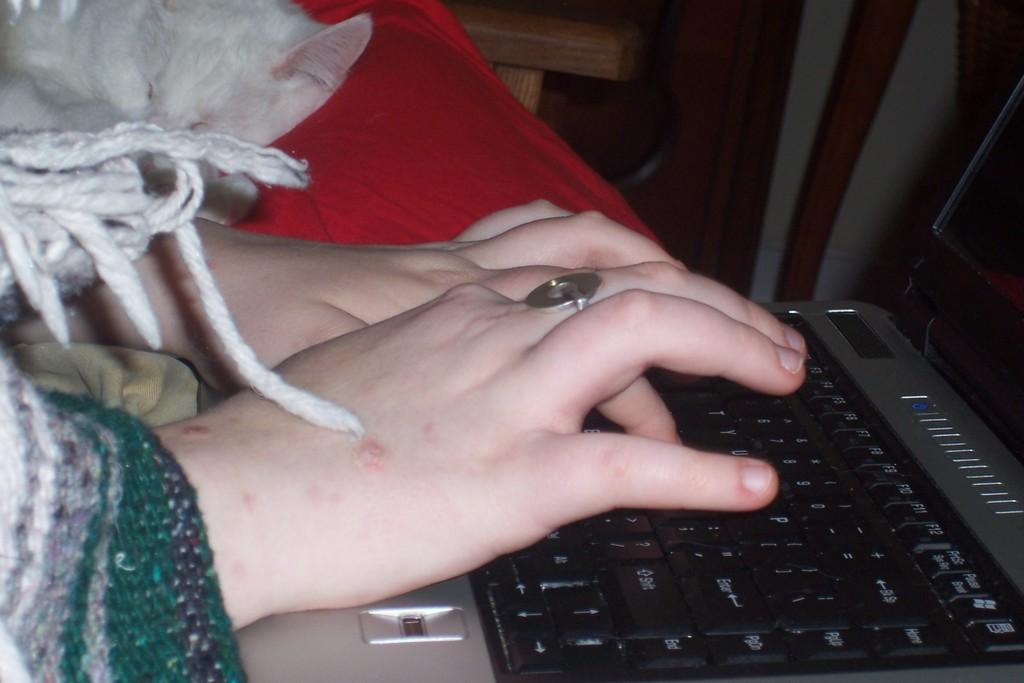What electronic device is being held by a person in the image? There is a laptop in the image, and a person is holding it. What part of the person's body is visible while holding the laptop? Fingers are visible in the image. What type of accessory is present on the person's hand? There is a hand ring in the image. What type of animal can be seen in the image? There is a cat in the image. What type of hat is the person wearing in the image? There is no hat visible in the image. What disease is the person suffering from in the image? There is no indication of any disease in the image. 